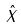<formula> <loc_0><loc_0><loc_500><loc_500>\hat { X }</formula> 